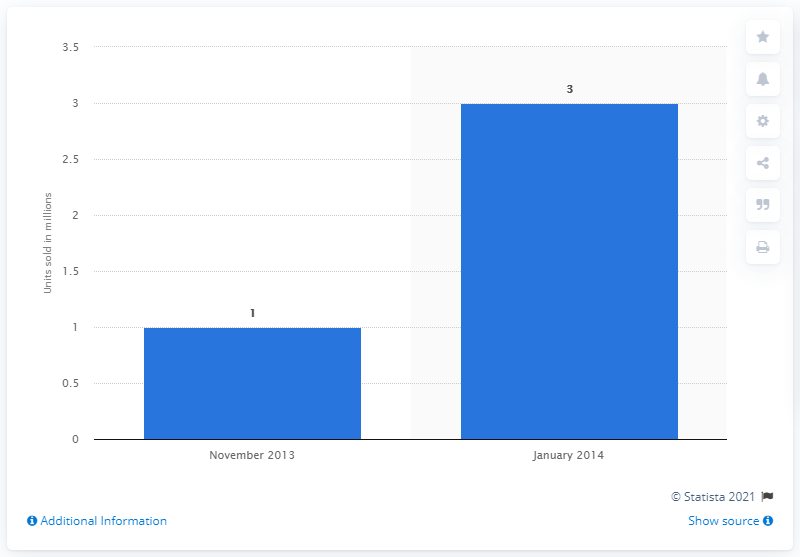Draw attention to some important aspects in this diagram. Infinity sold three million copies in January 2014. 